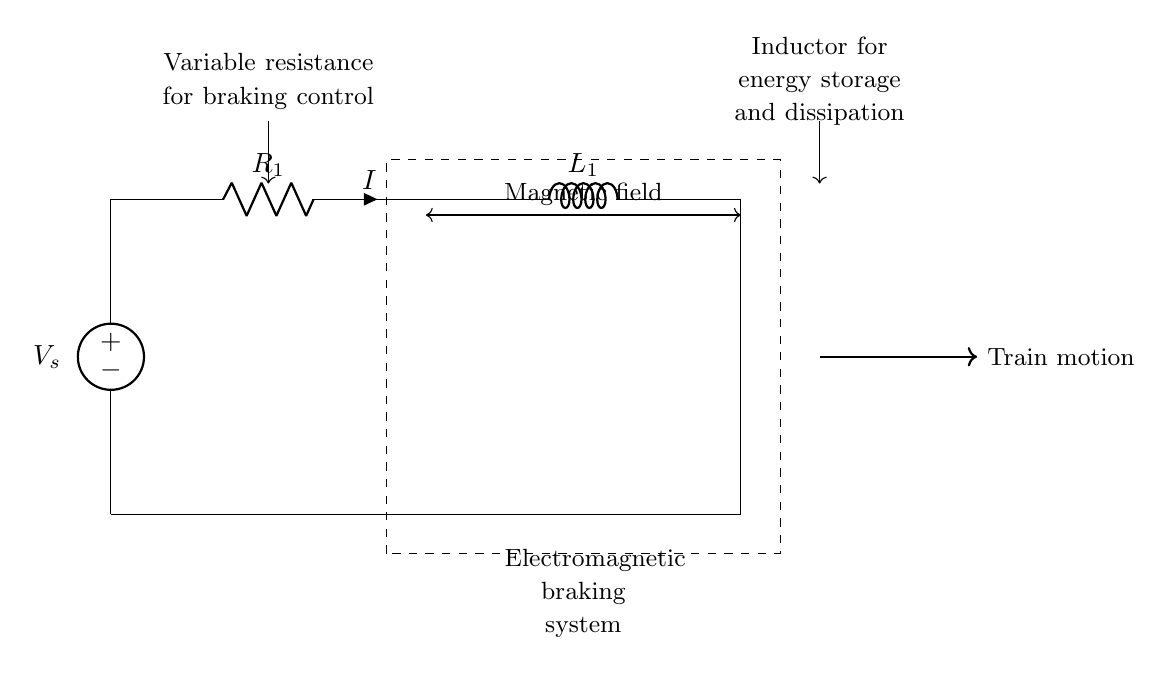What is the voltage source in the circuit? The voltage source is indicated as V_s, which provides the electrical potential for the circuit.
Answer: V_s What are the components present in the circuit? The components include a voltage source, a resistor, and an inductor, as depicted in the diagram.
Answer: Voltage source, resistor, inductor What is the function of the resistor in this RL circuit? The resistor controls the amount of current flowing through the circuit, thus affecting the braking capability.
Answer: Braking control What role does the inductor play in the electromagnetic braking system? The inductor stores energy and dissipates it, aiding in the rapid deceleration of the train when needed.
Answer: Energy storage and dissipation How does the magnetic field influence this circuit? The magnetic field affects the operation of the inductor, which is critical for the braking process, especially in terms of inducing opposing currents.
Answer: Induces opposing currents What happens when the resistance is varied in this circuit? Varying the resistance changes the current flow and affects the rate of energy dissipation, altering the braking force applied.
Answer: Changes braking force How does the system achieve rapid deceleration? The system utilizes the combined effect of the resistor and inductor to control current and thereby develop a rapid electromagnetic braking force.
Answer: Electromagnetic braking force 